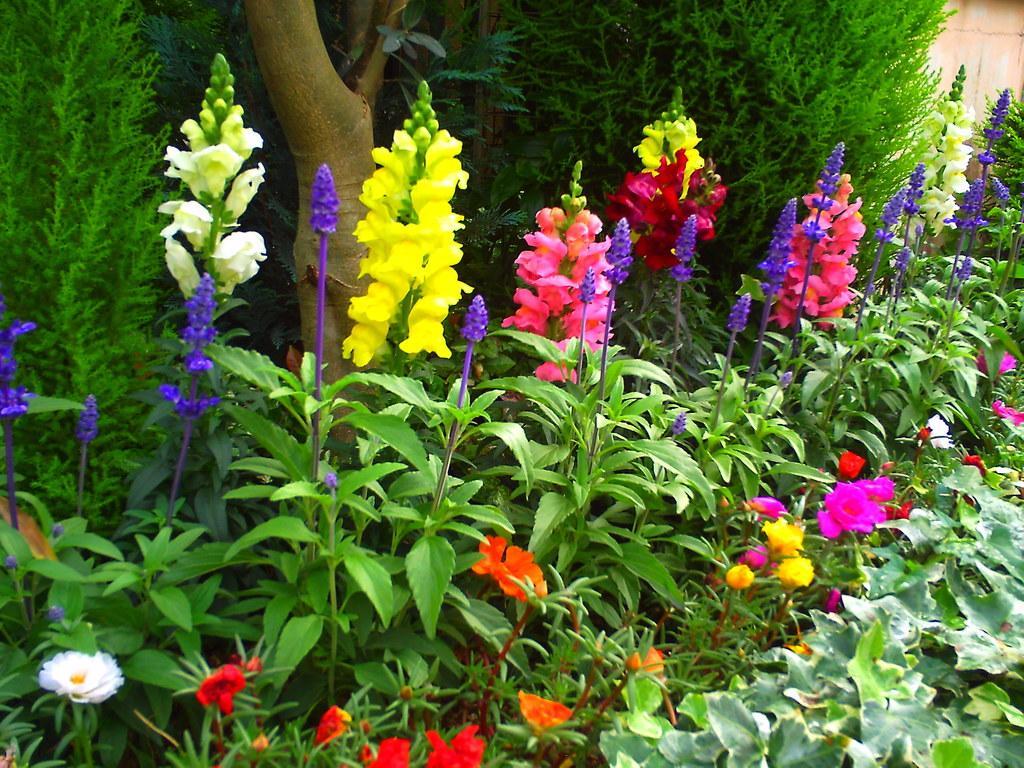Can you describe this image briefly? In the center of the image we can see plants with flowers. In the background there are bushes and trees. 